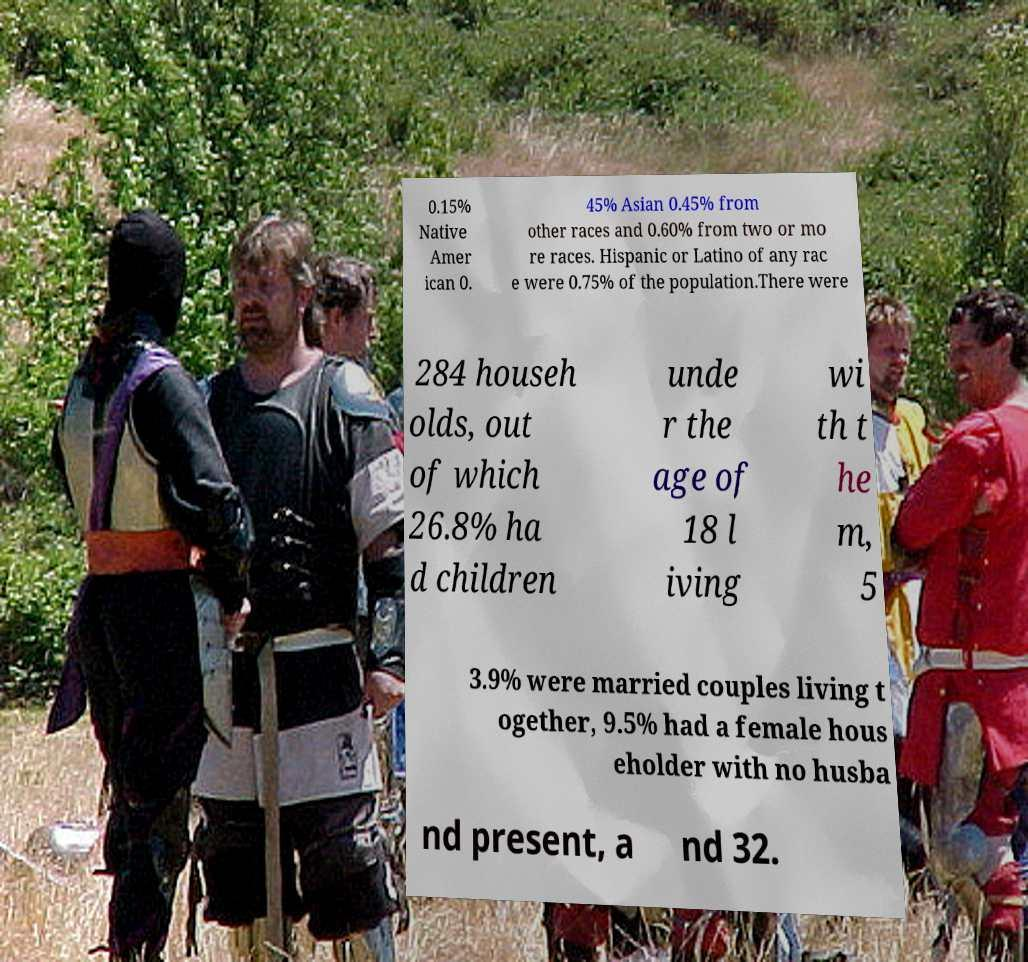Could you assist in decoding the text presented in this image and type it out clearly? 0.15% Native Amer ican 0. 45% Asian 0.45% from other races and 0.60% from two or mo re races. Hispanic or Latino of any rac e were 0.75% of the population.There were 284 househ olds, out of which 26.8% ha d children unde r the age of 18 l iving wi th t he m, 5 3.9% were married couples living t ogether, 9.5% had a female hous eholder with no husba nd present, a nd 32. 